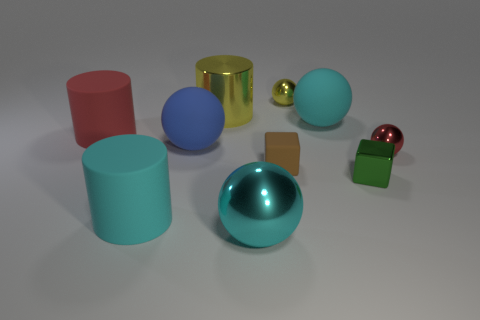Subtract all red spheres. How many spheres are left? 4 Subtract all large shiny balls. How many balls are left? 4 Subtract 2 balls. How many balls are left? 3 Subtract all red balls. Subtract all gray cubes. How many balls are left? 4 Subtract all blocks. How many objects are left? 8 Subtract 0 gray cylinders. How many objects are left? 10 Subtract all red cylinders. Subtract all blue spheres. How many objects are left? 8 Add 4 red rubber objects. How many red rubber objects are left? 5 Add 5 blue things. How many blue things exist? 6 